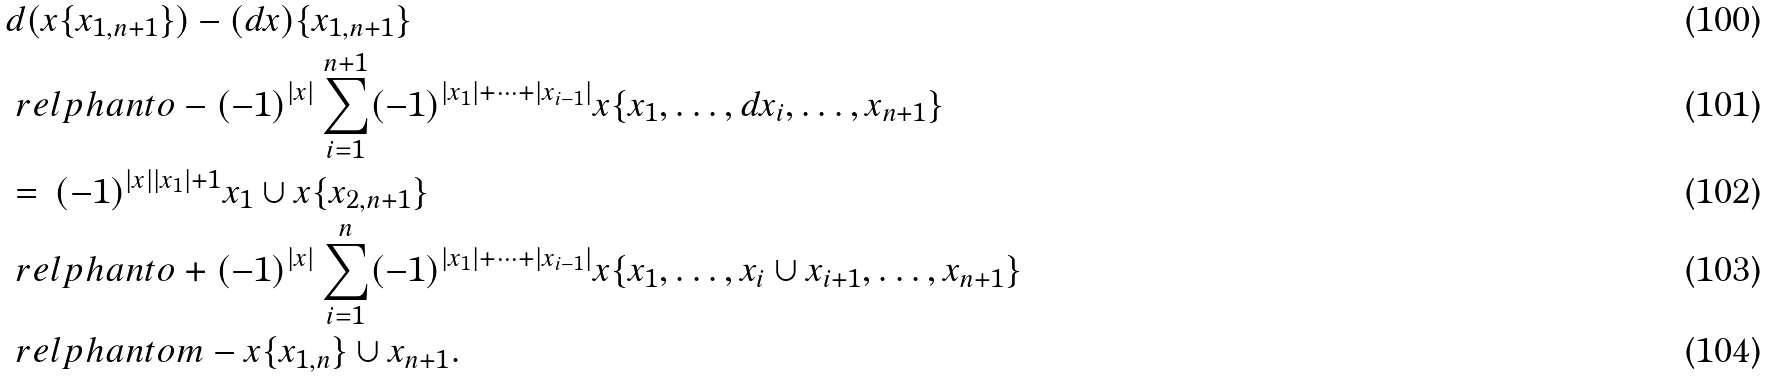Convert formula to latex. <formula><loc_0><loc_0><loc_500><loc_500>& d ( x \{ x _ { 1 , n + 1 } \} ) - ( d x ) \{ x _ { 1 , n + 1 } \} \\ & \ r e l p h a n t o - ( - 1 ) ^ { | x | } \sum _ { i = 1 } ^ { n + 1 } ( - 1 ) ^ { | x _ { 1 } | + \cdots + | x _ { i - 1 } | } x \{ x _ { 1 } , \dots , d x _ { i } , \dots , x _ { n + 1 } \} \\ & = \, ( - 1 ) ^ { | x | | x _ { 1 } | + 1 } x _ { 1 } \cup x \{ x _ { 2 , n + 1 } \} \\ & \ r e l p h a n t o + ( - 1 ) ^ { | x | } \sum _ { i = 1 } ^ { n } ( - 1 ) ^ { | x _ { 1 } | + \cdots + | x _ { i - 1 } | } x \{ x _ { 1 } , \dots , x _ { i } \cup x _ { i + 1 } , \dots , x _ { n + 1 } \} \\ & \ r e l p h a n t o m - x \{ x _ { 1 , n } \} \cup x _ { n + 1 } .</formula> 